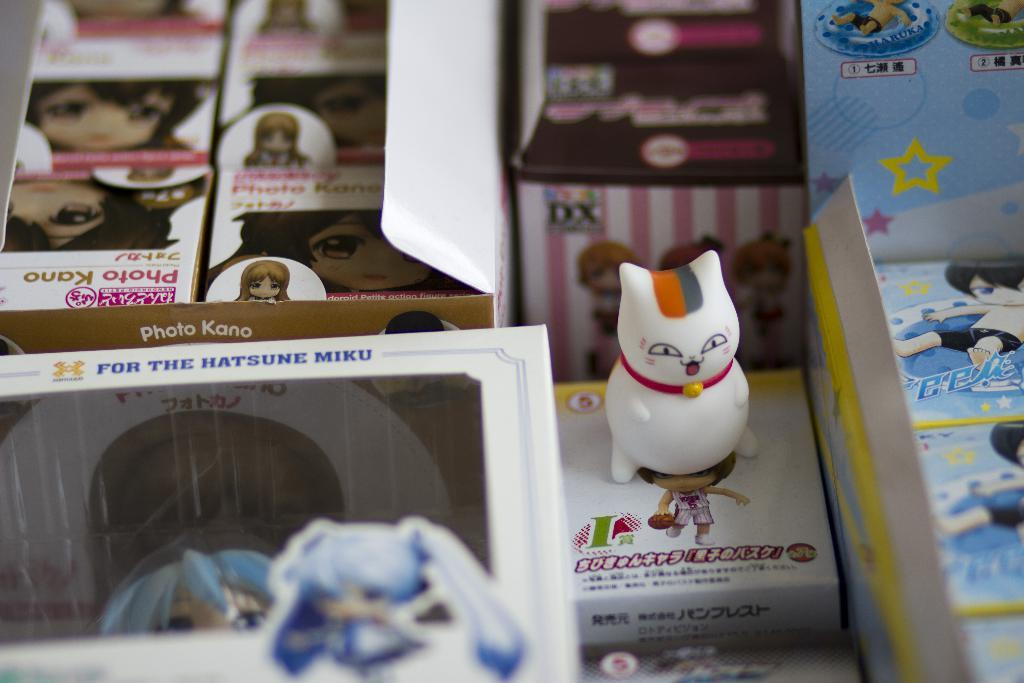<image>
Summarize the visual content of the image. A white ceramic cat sits on top of a box of packaging for different figurines, one being for For The Hatsune Miku. 